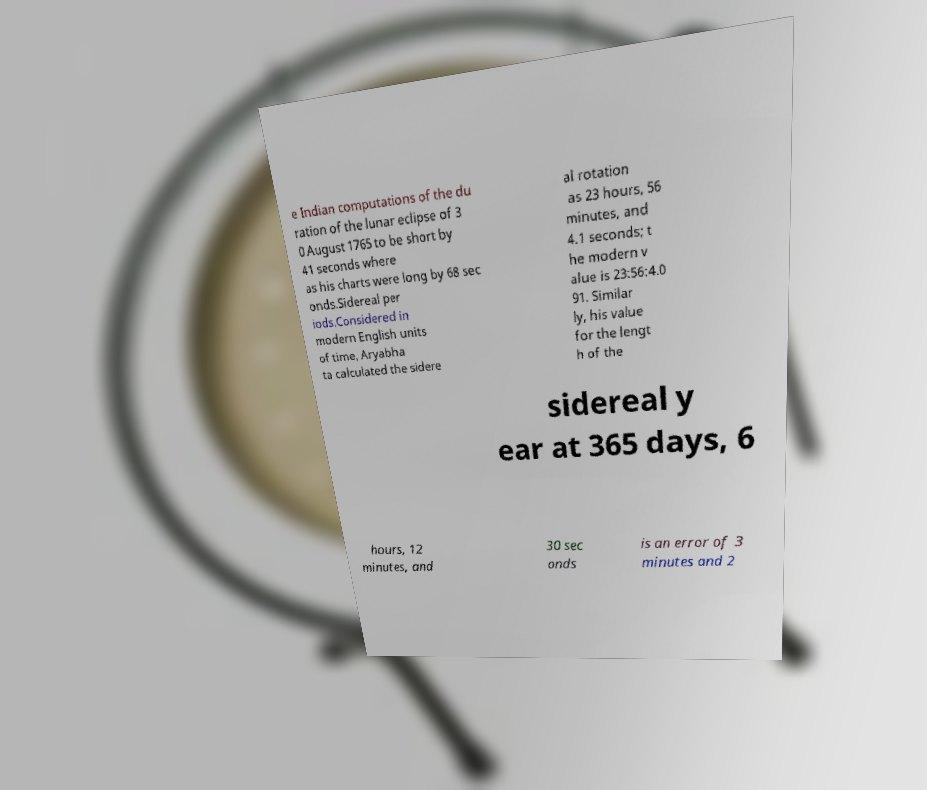Can you read and provide the text displayed in the image?This photo seems to have some interesting text. Can you extract and type it out for me? e Indian computations of the du ration of the lunar eclipse of 3 0 August 1765 to be short by 41 seconds where as his charts were long by 68 sec onds.Sidereal per iods.Considered in modern English units of time, Aryabha ta calculated the sidere al rotation as 23 hours, 56 minutes, and 4.1 seconds; t he modern v alue is 23:56:4.0 91. Similar ly, his value for the lengt h of the sidereal y ear at 365 days, 6 hours, 12 minutes, and 30 sec onds is an error of 3 minutes and 2 